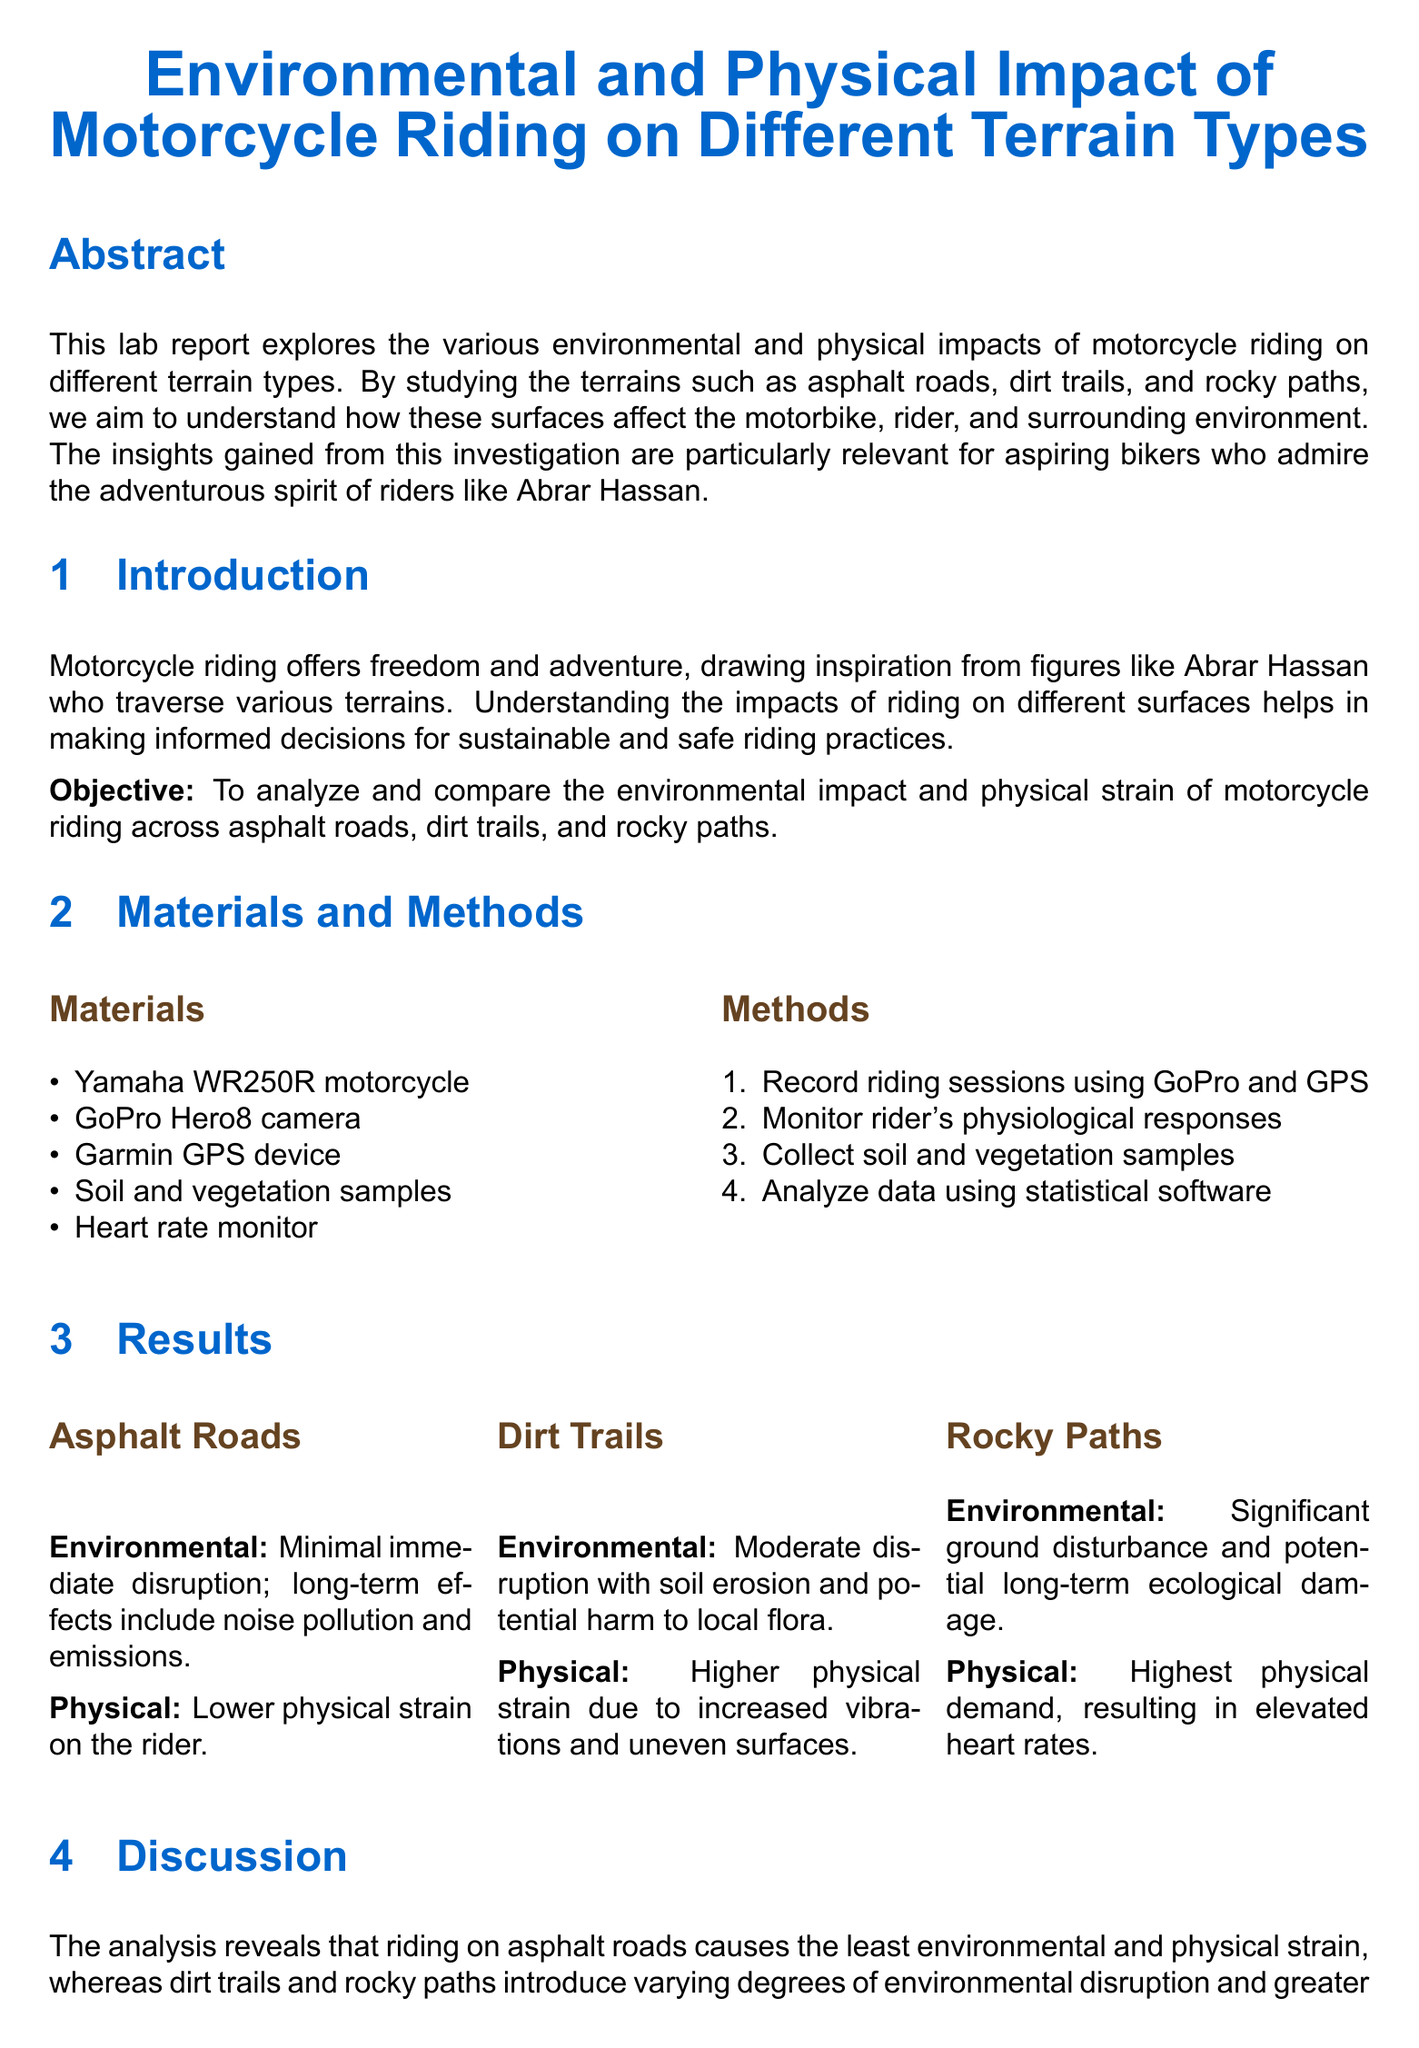What motorcycle model was used in the study? The Yamaha WR250R motorcycle is mentioned as the model used for the analysis.
Answer: Yamaha WR250R What type of camera was utilized to record riding sessions? The document specifies the use of a GoPro Hero8 camera for recording.
Answer: GoPro Hero8 What is the primary objective of the lab report? The objective is outlined in the introduction and focuses on analyzing and comparing impacts across different terrains.
Answer: To analyze and compare the environmental impact and physical strain of motorcycle riding across asphalt roads, dirt trails, and rocky paths Which terrain type has the highest physical demand for the rider? The results section indicates the highest physical demand occurs on rocky paths.
Answer: Rocky paths What environmental consequence is associated with riding on dirt trails? The document mentions moderate disruption, which includes soil erosion and potential harm to local flora.
Answer: Soil erosion and potential harm to local flora What type of analysis was used to evaluate the collected data? The methods section of the report states that statistical software was used for data analysis.
Answer: Statistical software What does the conclusion emphasize for bikers? The conclusion highlights the importance of balancing thrill and environmental awareness in biking practices.
Answer: Balancing the thrill of the ride with awareness of environmental conservation and physical health How many references are provided in the document? The references section lists three different sources supporting the study's findings.
Answer: Three 